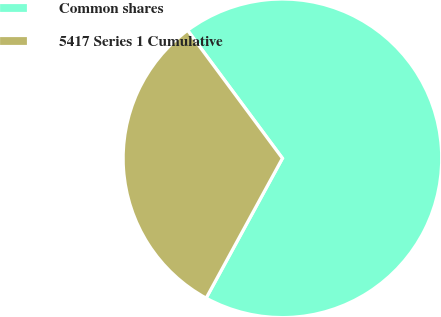<chart> <loc_0><loc_0><loc_500><loc_500><pie_chart><fcel>Common shares<fcel>5417 Series 1 Cumulative<nl><fcel>68.1%<fcel>31.9%<nl></chart> 